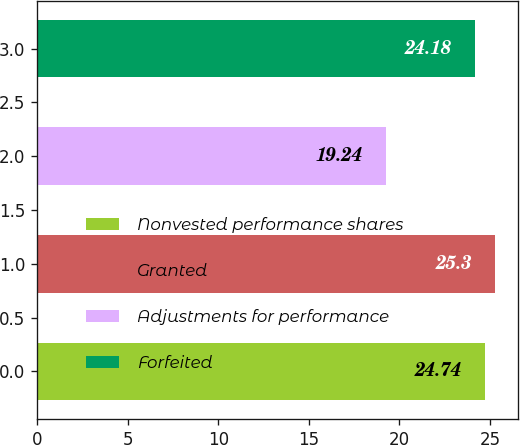Convert chart. <chart><loc_0><loc_0><loc_500><loc_500><bar_chart><fcel>Nonvested performance shares<fcel>Granted<fcel>Adjustments for performance<fcel>Forfeited<nl><fcel>24.74<fcel>25.3<fcel>19.24<fcel>24.18<nl></chart> 